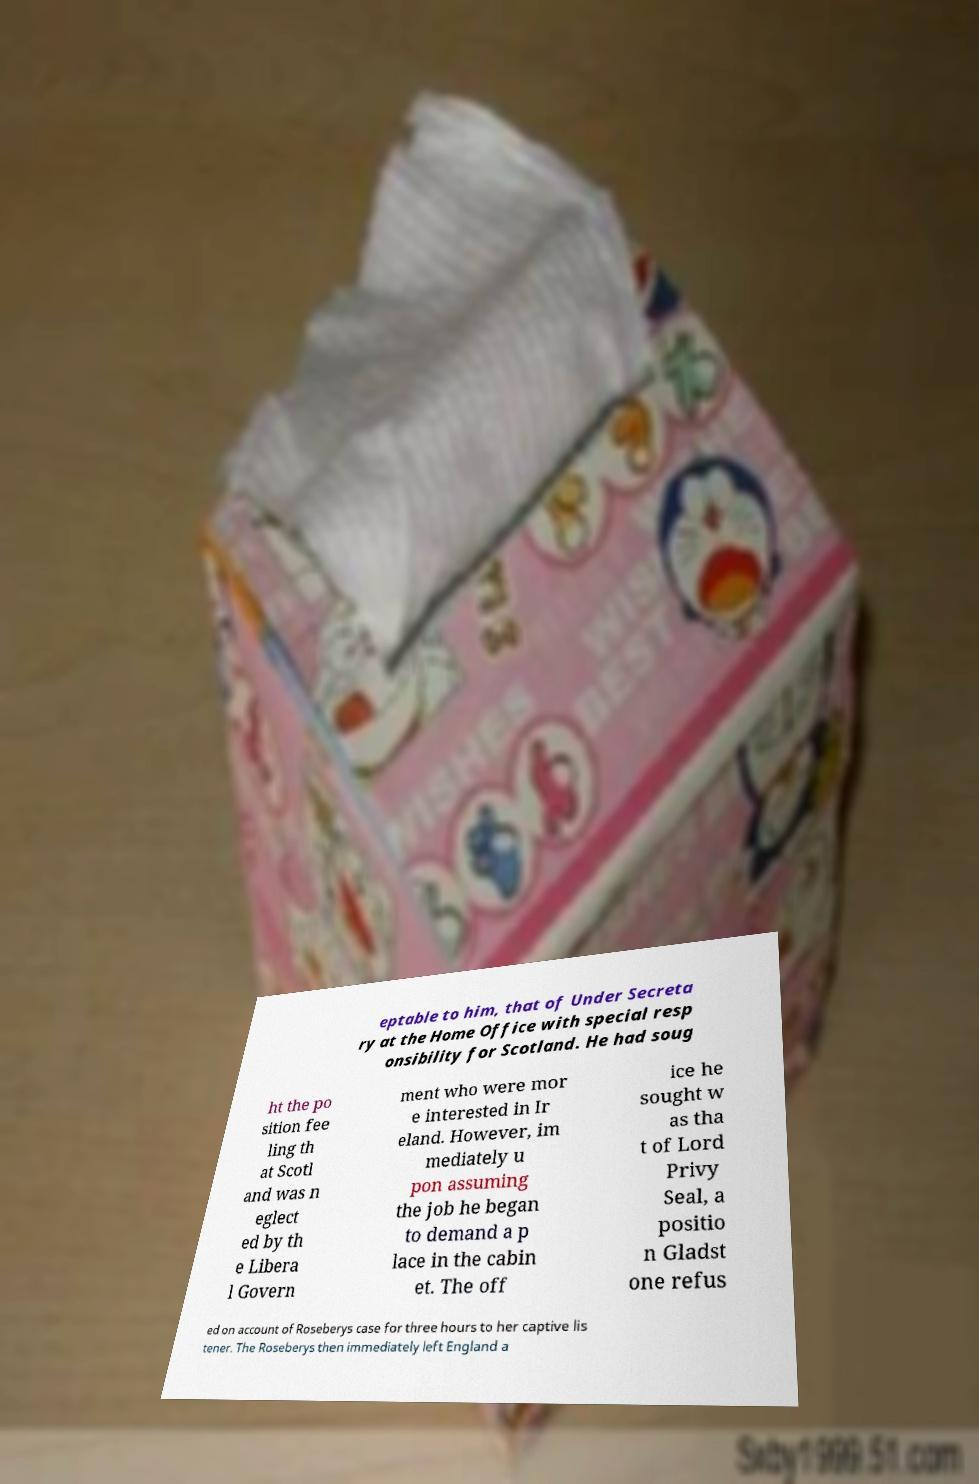I need the written content from this picture converted into text. Can you do that? eptable to him, that of Under Secreta ry at the Home Office with special resp onsibility for Scotland. He had soug ht the po sition fee ling th at Scotl and was n eglect ed by th e Libera l Govern ment who were mor e interested in Ir eland. However, im mediately u pon assuming the job he began to demand a p lace in the cabin et. The off ice he sought w as tha t of Lord Privy Seal, a positio n Gladst one refus ed on account of Roseberys case for three hours to her captive lis tener. The Roseberys then immediately left England a 